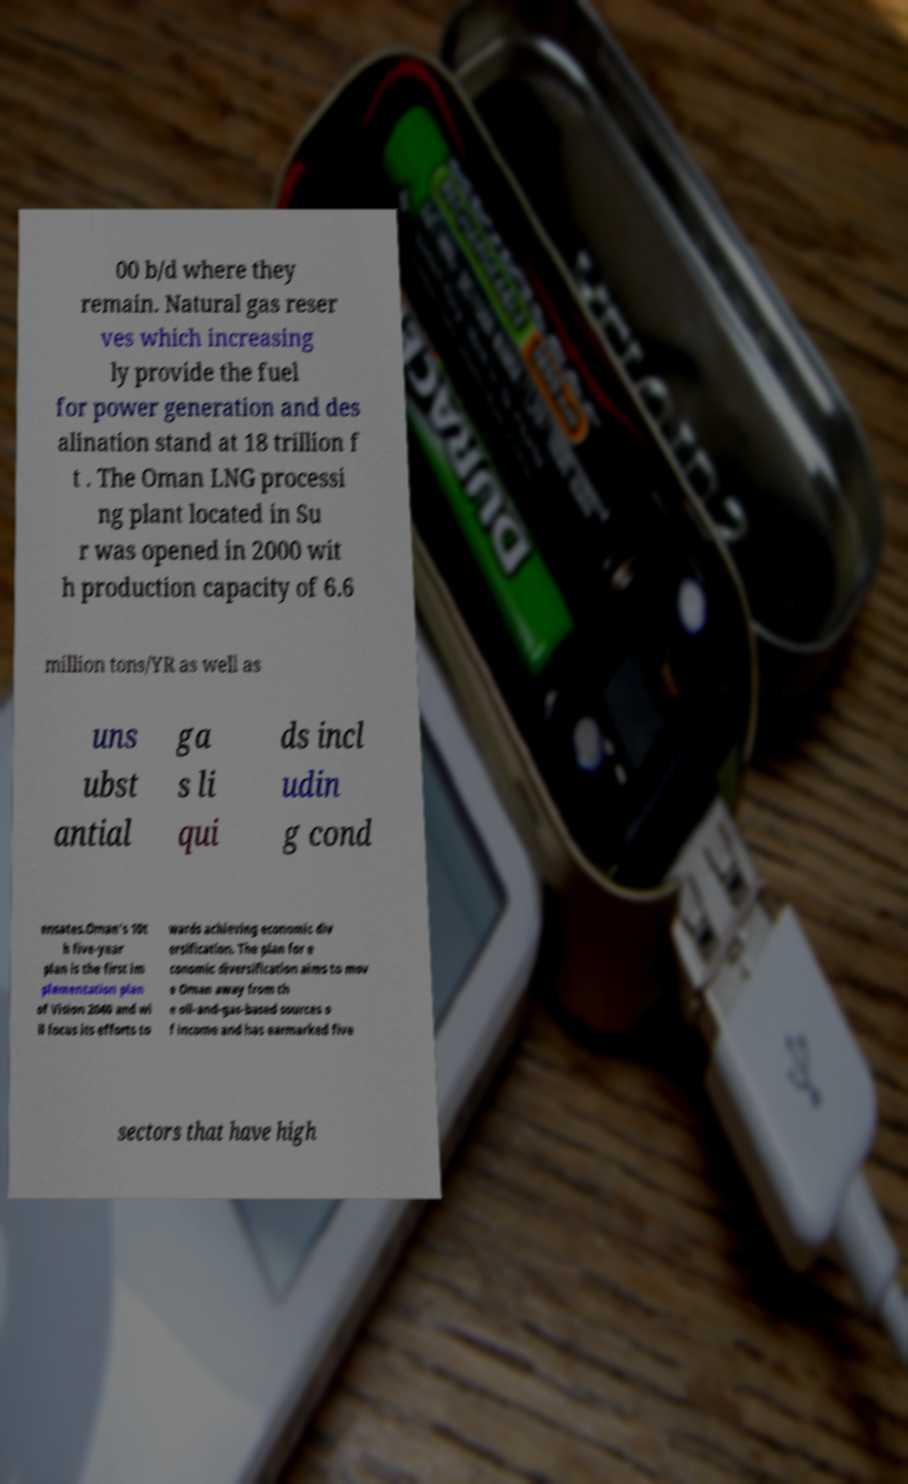I need the written content from this picture converted into text. Can you do that? 00 b/d where they remain. Natural gas reser ves which increasing ly provide the fuel for power generation and des alination stand at 18 trillion f t . The Oman LNG processi ng plant located in Su r was opened in 2000 wit h production capacity of 6.6 million tons/YR as well as uns ubst antial ga s li qui ds incl udin g cond ensates.Oman's 10t h five-year plan is the first im plementation plan of Vision 2040 and wi ll focus its efforts to wards achieving economic div ersification. The plan for e conomic diversification aims to mov e Oman away from th e oil-and-gas-based sources o f income and has earmarked five sectors that have high 